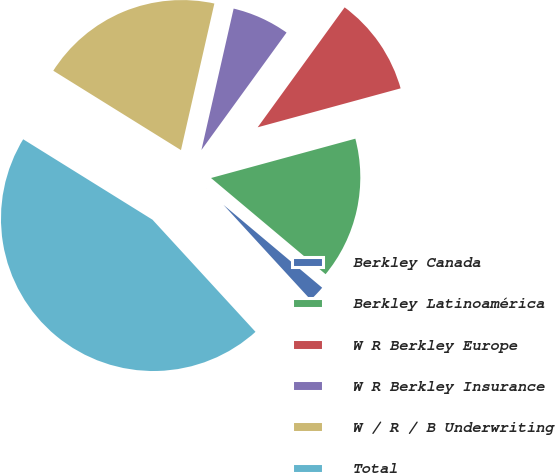Convert chart to OTSL. <chart><loc_0><loc_0><loc_500><loc_500><pie_chart><fcel>Berkley Canada<fcel>Berkley Latinoamérica<fcel>W R Berkley Europe<fcel>W R Berkley Insurance<fcel>W / R / B Underwriting<fcel>Total<nl><fcel>2.06%<fcel>15.35%<fcel>10.78%<fcel>6.42%<fcel>19.71%<fcel>45.68%<nl></chart> 